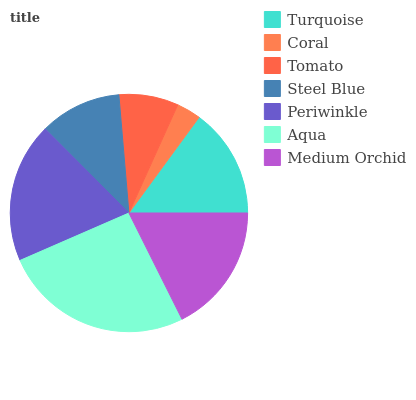Is Coral the minimum?
Answer yes or no. Yes. Is Aqua the maximum?
Answer yes or no. Yes. Is Tomato the minimum?
Answer yes or no. No. Is Tomato the maximum?
Answer yes or no. No. Is Tomato greater than Coral?
Answer yes or no. Yes. Is Coral less than Tomato?
Answer yes or no. Yes. Is Coral greater than Tomato?
Answer yes or no. No. Is Tomato less than Coral?
Answer yes or no. No. Is Turquoise the high median?
Answer yes or no. Yes. Is Turquoise the low median?
Answer yes or no. Yes. Is Tomato the high median?
Answer yes or no. No. Is Aqua the low median?
Answer yes or no. No. 